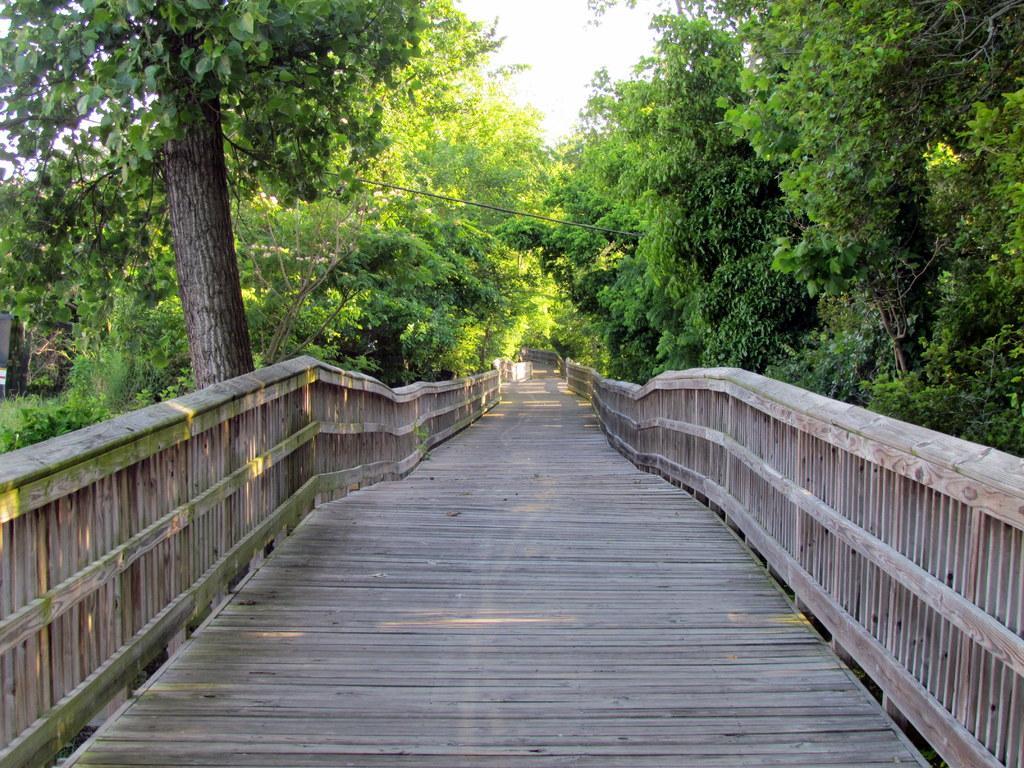Describe this image in one or two sentences. In the picture we can see wooden walkway, there are some trees on left and right side of the picture and top of the picture there is clear sky. 